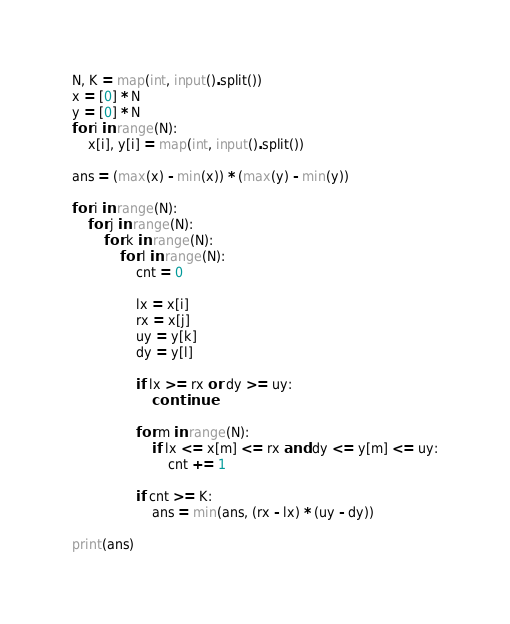<code> <loc_0><loc_0><loc_500><loc_500><_Python_>N, K = map(int, input().split())
x = [0] * N
y = [0] * N
for i in range(N):
    x[i], y[i] = map(int, input().split())

ans = (max(x) - min(x)) * (max(y) - min(y))

for i in range(N):
    for j in range(N):
        for k in range(N):
            for l in range(N):
                cnt = 0

                lx = x[i]
                rx = x[j]
                uy = y[k]
                dy = y[l]

                if lx >= rx or dy >= uy:
                    continue

                for m in range(N):
                    if lx <= x[m] <= rx and dy <= y[m] <= uy:
                        cnt += 1

                if cnt >= K:
                    ans = min(ans, (rx - lx) * (uy - dy))

print(ans)</code> 